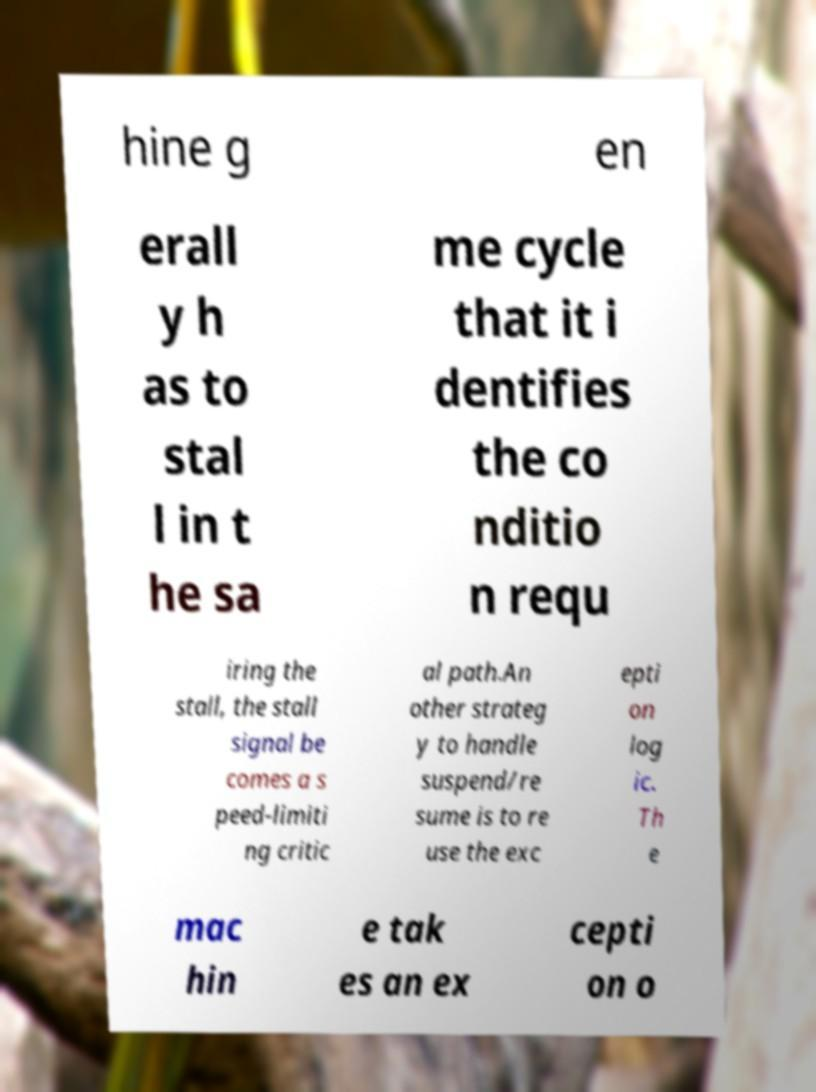Can you accurately transcribe the text from the provided image for me? hine g en erall y h as to stal l in t he sa me cycle that it i dentifies the co nditio n requ iring the stall, the stall signal be comes a s peed-limiti ng critic al path.An other strateg y to handle suspend/re sume is to re use the exc epti on log ic. Th e mac hin e tak es an ex cepti on o 